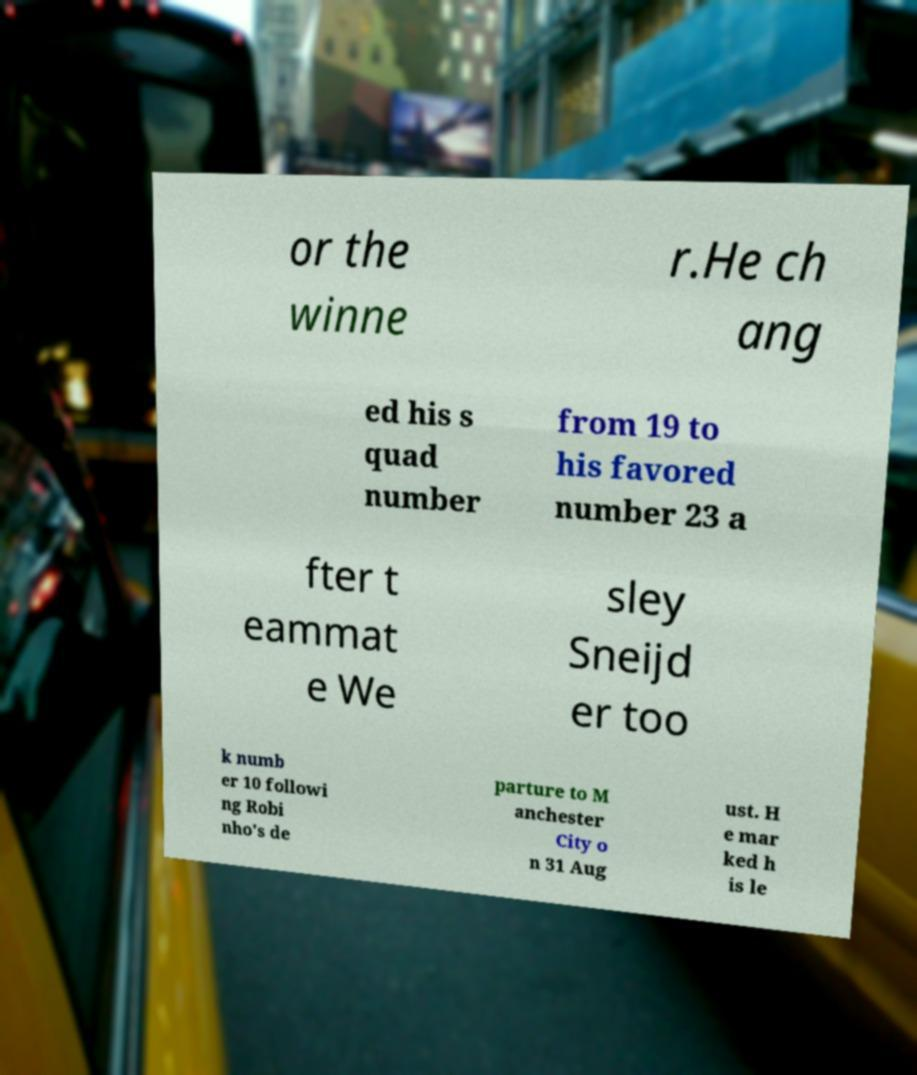For documentation purposes, I need the text within this image transcribed. Could you provide that? or the winne r.He ch ang ed his s quad number from 19 to his favored number 23 a fter t eammat e We sley Sneijd er too k numb er 10 followi ng Robi nho's de parture to M anchester City o n 31 Aug ust. H e mar ked h is le 